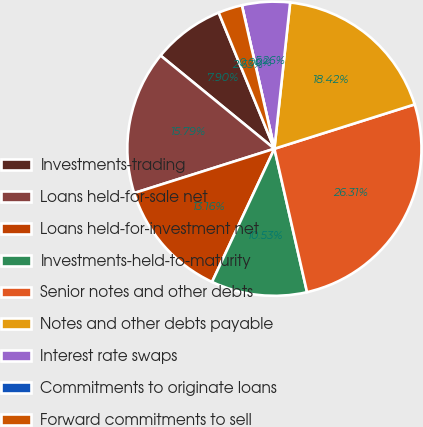<chart> <loc_0><loc_0><loc_500><loc_500><pie_chart><fcel>Investments-trading<fcel>Loans held-for-sale net<fcel>Loans held-for-investment net<fcel>Investments-held-to-maturity<fcel>Senior notes and other debts<fcel>Notes and other debts payable<fcel>Interest rate swaps<fcel>Commitments to originate loans<fcel>Forward commitments to sell<nl><fcel>7.9%<fcel>15.79%<fcel>13.16%<fcel>10.53%<fcel>26.31%<fcel>18.42%<fcel>5.26%<fcel>0.0%<fcel>2.63%<nl></chart> 